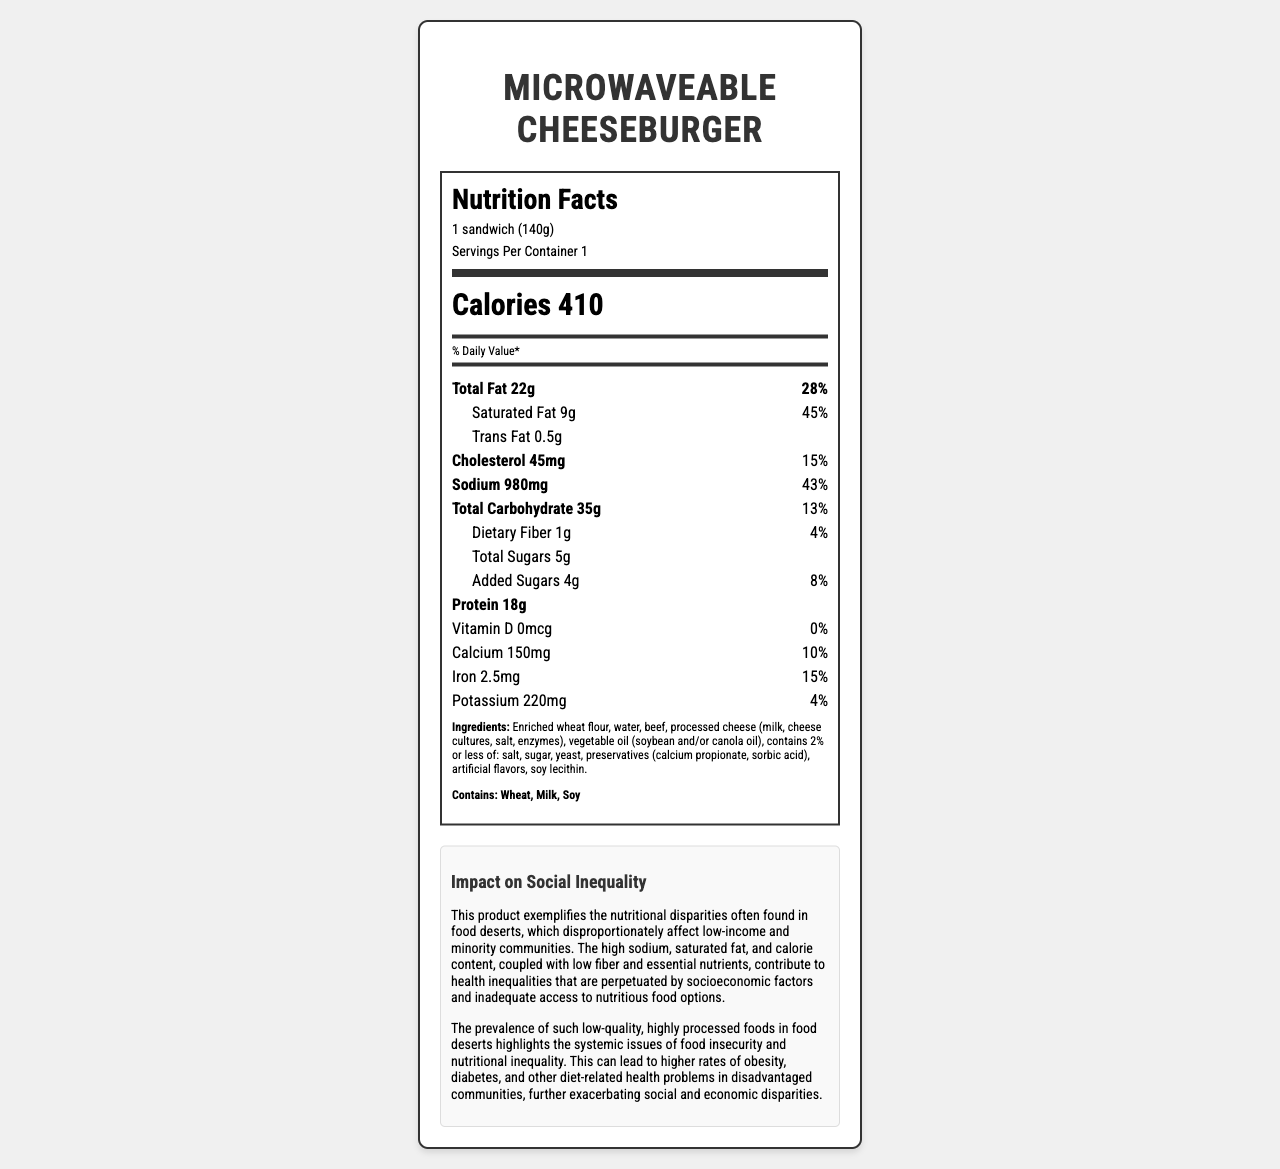what is the serving size? The serving size is clearly mentioned under the heading "Nutrition Facts" as "1 sandwich (140g)".
Answer: 1 sandwich (140g) how many calories are in one serving? The calories per serving are prominently displayed in the label, right below the serving size information.
Answer: 410 what is the total fat content, and what percentage of the daily value does it represent? The document states "Total Fat 22g" and "28%" next to it, indicating the amount and the percentage of daily value.
Answer: 22g, 28% how much saturated fat does the product contain? The saturated fat content is listed under total fat with an amount of 9g.
Answer: 9g what percentage of the daily value does the sodium content represent? The sodium content represents 43% of the daily value, as indicated next to the sodium amount of 980mg.
Answer: 43% what are the allergens present in the product? The allergens are listed at the bottom of the label in bold as "Contains: Wheat, Milk, Soy".
Answer: Wheat, Milk, Soy how does the product exemplify nutritional disparities in food deserts? The document explains this under the impact section stating that the product's poor nutritional quality highlights the disparities in food deserts.
Answer: High sodium, saturated fat, and calories, with low fiber and essential nutrients. how much protein does this cheeseburger contain? The document shows "Protein 18g" clearly as a separate item in the nutrient list.
Answer: 18g does this product contain any vitamin D? The vitamin D content is listed as 0 mcg, which means it does not contain any vitamin D.
Answer: No what is the main impact on social inequality mentioned in the document? The document explains that the poor nutritional quality contributes to health inequalities, which affects low-income and minority communities due to inadequate access to nutritious food options.
Answer: Contributes to health inequalities in low-income and minority communities which nutrient is present in the highest amount per serving? A. Sodium B. Cholesterol C. Carbohydrates D. Dietary Fiber Among the listed nutrients, Sodium (980mg) is present in the highest amount per serving.
Answer: A. Sodium what is the percentage of daily value for calcium in this product? A. 15% B. 43% C. 10% D. 4% The document lists the calcium daily value percentage as 10%.
Answer: C. 10% does the product contain added sugars? The document states that the product contains 4g of added sugars.
Answer: Yes summarize the nutritional concerns listed for this Microwaveable Cheeseburger. The nutritional concerns include high calorie, fat, and sodium levels, with very little dietary fiber and essential nutrients, contributing to poor health outcomes and social inequalities.
Answer: The cheeseburger has high calorie content (410), high total fat (22g) and saturated fat (9g), significant sodium content (980mg), low dietary fiber (1g), and minimal amounts of essential nutrients like vitamin D. This poor nutritional profile contributes to health disparities in communities. what is the impact of this product on potassium intake? The document states that the product contains 220mg of potassium, which contributes to 4% of the daily value.
Answer: 220mg, 4% of daily value how many servings are in one container? The number of servings per container is mentioned as 1 under the serving size section.
Answer: 1 what is the percentage of daily value for iron in this product? The document lists the iron daily value percentage as 15%.
Answer: 15% does the document provide information about the origin of the beef used? There is no information in the document about the origin of the beef used in the product.
Answer: No cannot answer how many preservatives are in the product? The document lists some preservatives like calcium propionate and sorbic acid but does not provide the exact number of preservatives.
Answer: Not enough information 